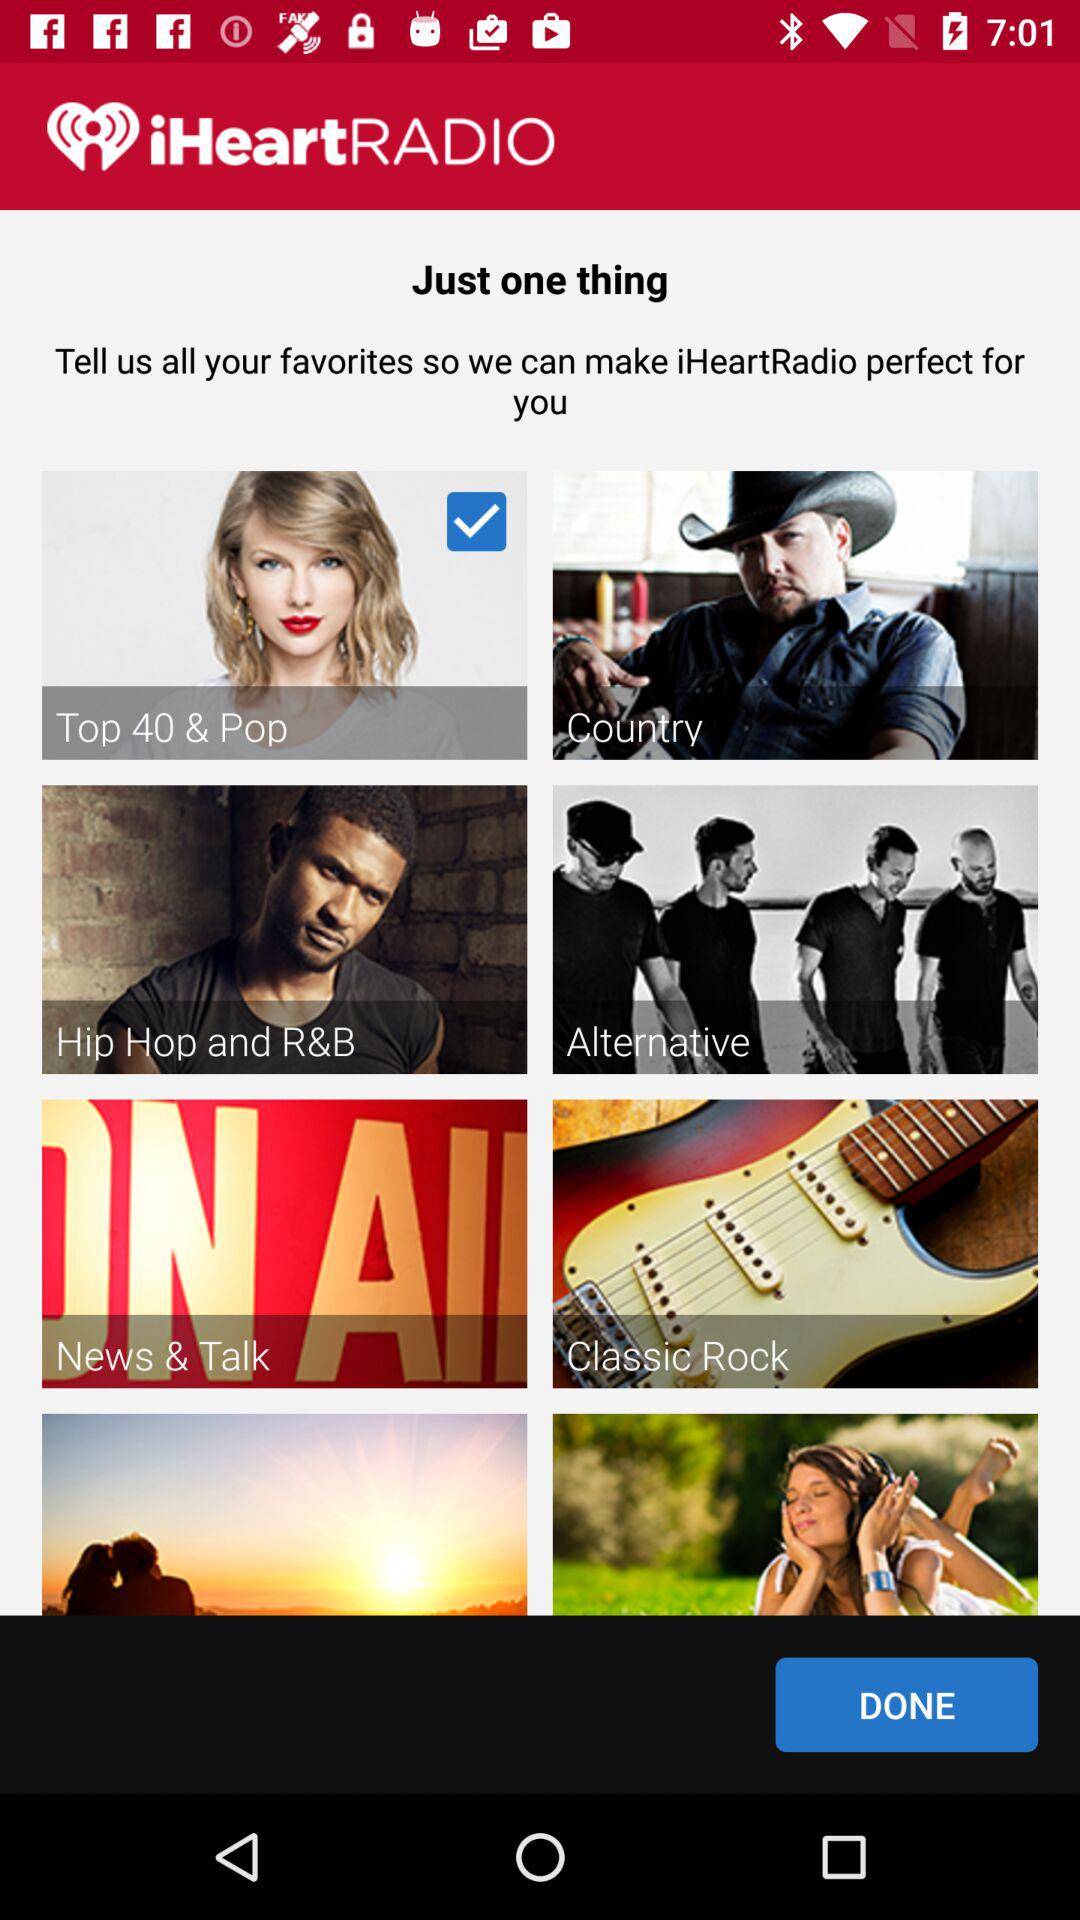What option has been selected? The option "Top 40 & Pop" has been selected. 